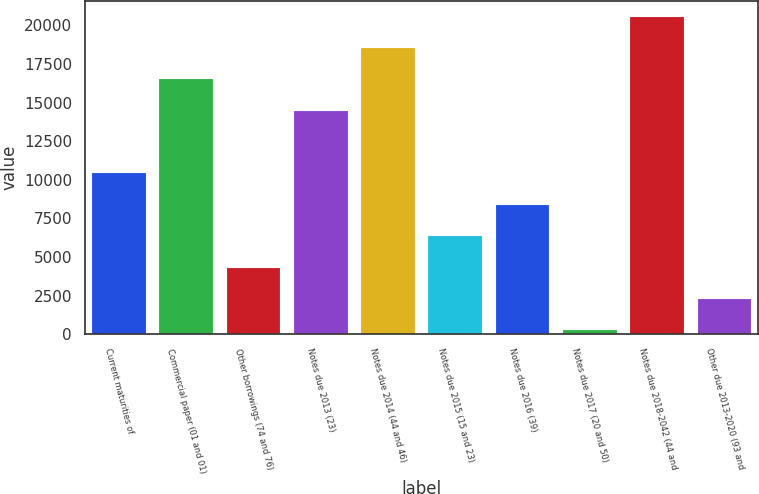Convert chart to OTSL. <chart><loc_0><loc_0><loc_500><loc_500><bar_chart><fcel>Current maturities of<fcel>Commercial paper (01 and 01)<fcel>Other borrowings (74 and 76)<fcel>Notes due 2013 (23)<fcel>Notes due 2014 (44 and 46)<fcel>Notes due 2015 (15 and 23)<fcel>Notes due 2016 (39)<fcel>Notes due 2017 (20 and 50)<fcel>Notes due 2018-2042 (44 and<fcel>Other due 2013-2020 (93 and<nl><fcel>10413<fcel>16506<fcel>4320<fcel>14475<fcel>18537<fcel>6351<fcel>8382<fcel>258<fcel>20568<fcel>2289<nl></chart> 